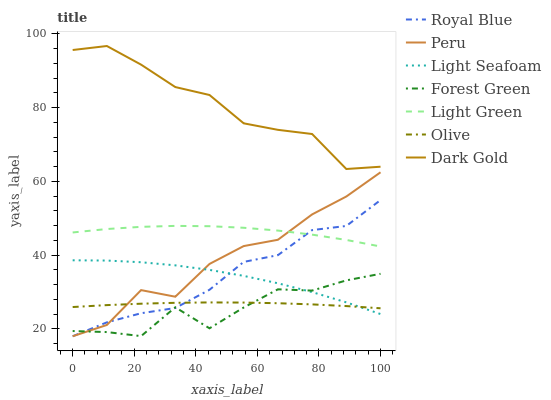Does Forest Green have the minimum area under the curve?
Answer yes or no. Yes. Does Dark Gold have the maximum area under the curve?
Answer yes or no. Yes. Does Royal Blue have the minimum area under the curve?
Answer yes or no. No. Does Royal Blue have the maximum area under the curve?
Answer yes or no. No. Is Olive the smoothest?
Answer yes or no. Yes. Is Forest Green the roughest?
Answer yes or no. Yes. Is Dark Gold the smoothest?
Answer yes or no. No. Is Dark Gold the roughest?
Answer yes or no. No. Does Peru have the lowest value?
Answer yes or no. Yes. Does Dark Gold have the lowest value?
Answer yes or no. No. Does Dark Gold have the highest value?
Answer yes or no. Yes. Does Royal Blue have the highest value?
Answer yes or no. No. Is Olive less than Dark Gold?
Answer yes or no. Yes. Is Light Green greater than Forest Green?
Answer yes or no. Yes. Does Light Green intersect Peru?
Answer yes or no. Yes. Is Light Green less than Peru?
Answer yes or no. No. Is Light Green greater than Peru?
Answer yes or no. No. Does Olive intersect Dark Gold?
Answer yes or no. No. 